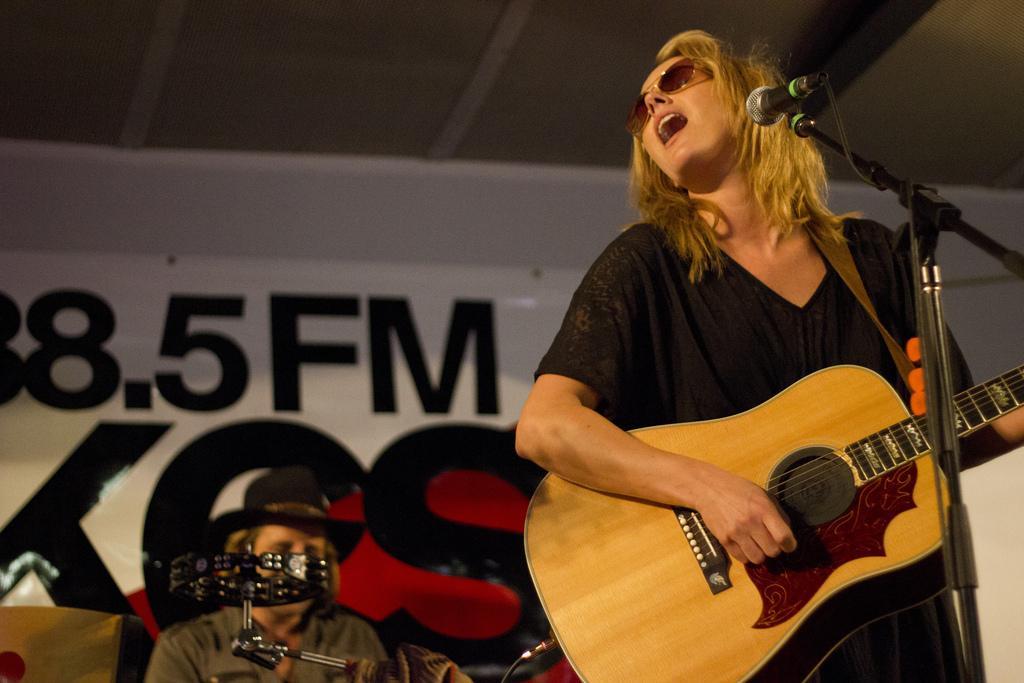In one or two sentences, can you explain what this image depicts? This woman wore black dress, goggles and playing guitar in-front of mic. This is a mic holder. This man is sitting and wore hat. This is a musical instrument. A banner on wall. 